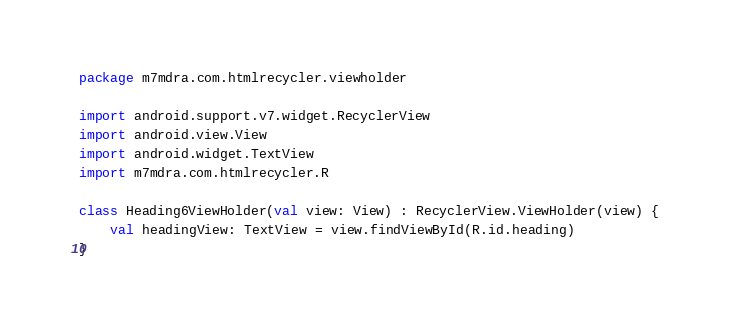<code> <loc_0><loc_0><loc_500><loc_500><_Kotlin_>package m7mdra.com.htmlrecycler.viewholder

import android.support.v7.widget.RecyclerView
import android.view.View
import android.widget.TextView
import m7mdra.com.htmlrecycler.R

class Heading6ViewHolder(val view: View) : RecyclerView.ViewHolder(view) {
    val headingView: TextView = view.findViewById(R.id.heading)
}</code> 